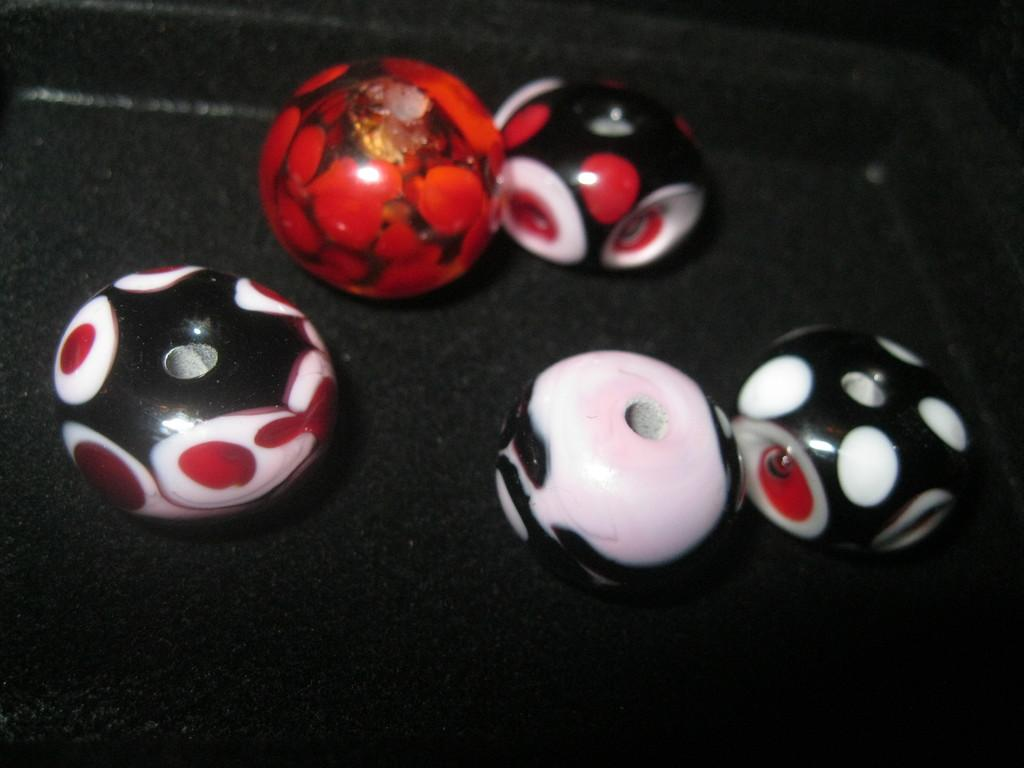What is the shape of the objects in the image? The objects in the image are round. Where are the round objects located? The round objects are on a platform. What type of grass is growing around the round objects in the image? There is no grass present in the image; it only features round objects on a platform. 